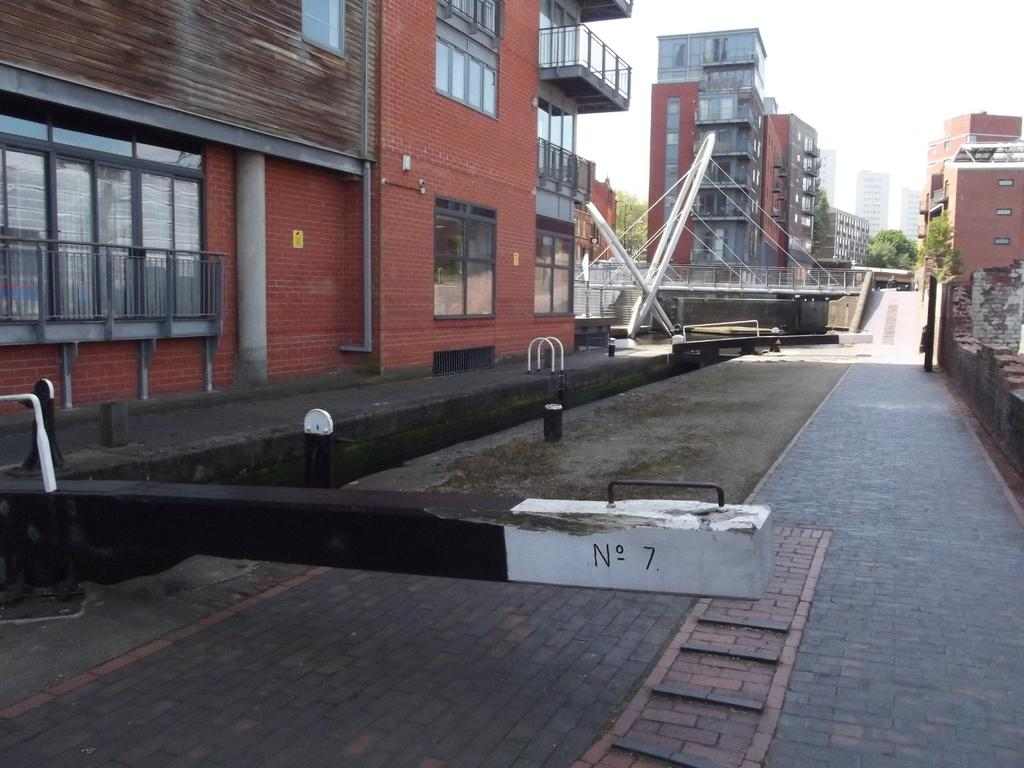What type of structures can be seen in the image? There are buildings in the image. What other natural elements are present in the image? There are trees in the image. How would you describe the sky in the image? The sky is cloudy in the image. What type of powder is being used for digestion in the image? There is no reference to powder or digestion in the image; it features buildings, trees, and a cloudy sky. 